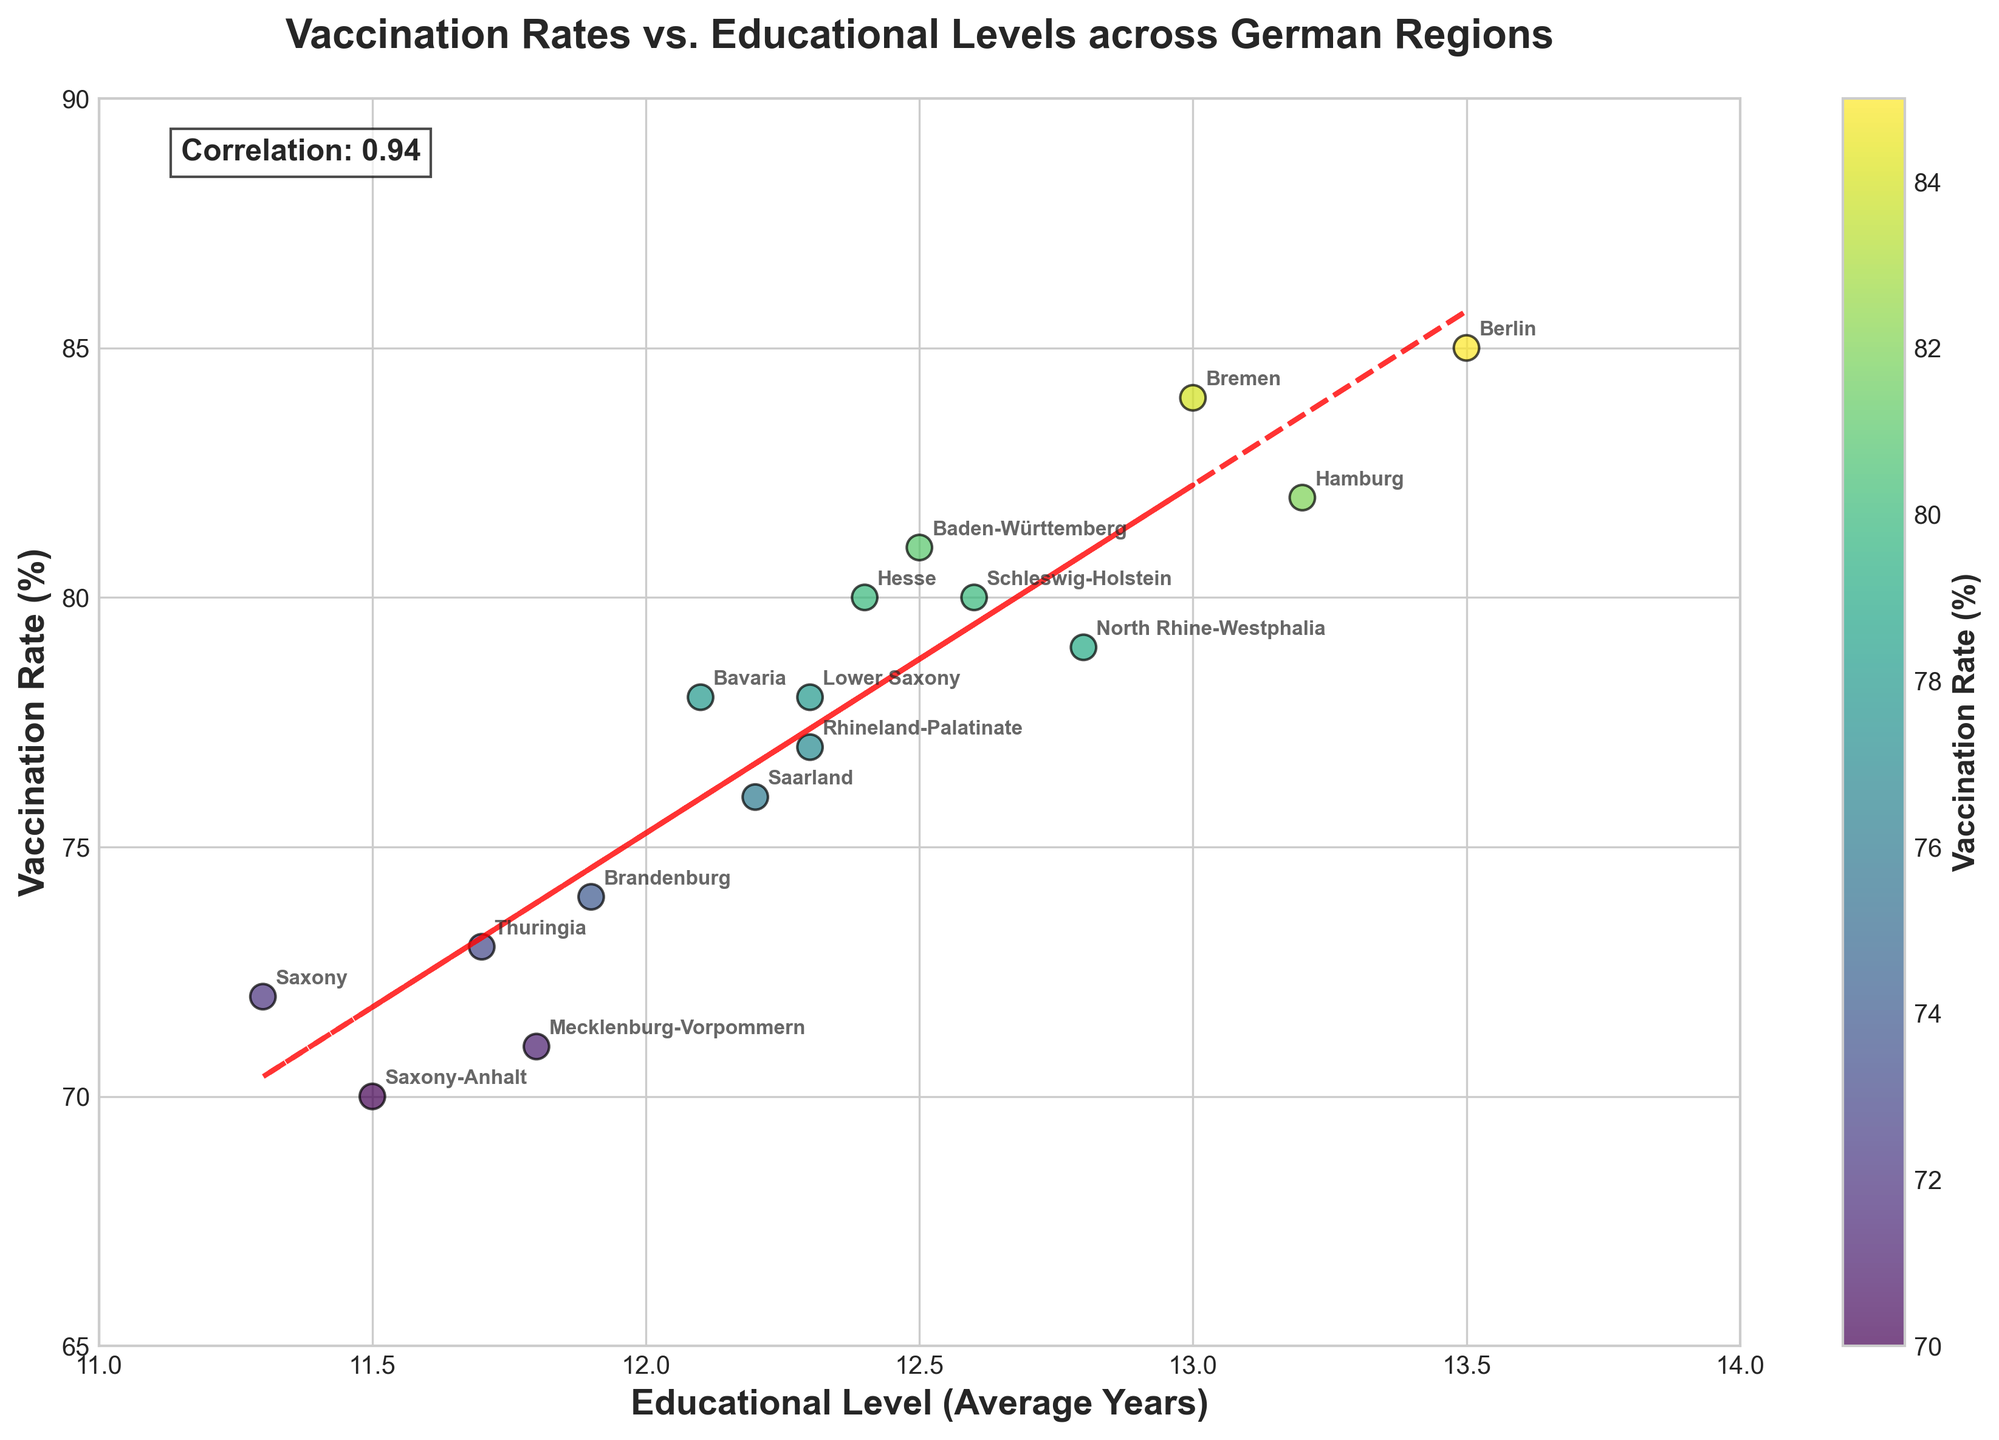What is the title of the figure? The title of the figure is located at the top center. It reads "Vaccination Rates vs. Educational Levels across German Regions." This title directly indicates the relationship being explored in the scatter plot.
Answer: Vaccination Rates vs. Educational Levels across German Regions What are the X-axis and Y-axis labels? The X-axis label is "Educational Level (Average Years)," and the Y-axis label is "Vaccination Rate (%)". These labels provide the variables being plotted on each axis.
Answer: Educational Level (Average Years), Vaccination Rate (%) Which region has the highest vaccination rate? The highest vaccination rate can be identified by looking for the point that is the farthest up along the Y-axis. According to the annotations, Berlin has the highest vaccination rate at 85%.
Answer: Berlin What is the average vaccination rate across all regions? To find the average vaccination rate, sum up all the vaccination rates and then divide by the number of regions. The sum is 78 + 85 + 82 + 72 + 81 + 79 + 80 + 77 + 84 + 76 + 78 + 71 + 70 + 73 + 80 + 74 = 1200. There are 16 regions, so the average is 1200 / 16.
Answer: 75% What is the correlation coefficient between educational level and vaccination rate, and what does it imply? The correlation coefficient is shown as a text box within the plot. It indicates how strongly the two variables are related. The figure shows a correlation coefficient of about 0.81, implying a strong positive relationship between educational level and vaccination rate.
Answer: 0.81 How does the vaccination rate for Bavaria compare to that of Hesse? To compare the vaccination rates, look for the points corresponding to Bavaria and Hesse. Bavaria has a vaccination rate of 78%, while Hesse has a rate of 80%, so Hesse has a slightly higher vaccination rate than Bavaria by 2 percentage points.
Answer: Hesse is higher Which region has the lowest educational level, and what is its vaccination rate? The region with the lowest educational level can be found by identifying the point farthest to the left on the X-axis. Saxony-Anhalt has the lowest educational level at 11.5 years, with a corresponding vaccination rate of 70%.
Answer: Saxony-Anhalt, 70% What trend can be observed from the trend line in the scatter plot? The trend line in the scatter plot shows an upward slope, indicating that as the educational level increases, the vaccination rate also tends to increase. This suggests a positive relationship between the two variables.
Answer: As educational level increases, vaccination rate increases What is the vaccination rate in Schleswig-Holstein, and how does it compare to the overall average? The point for Schleswig-Holstein shows a vaccination rate of 80%. The overall average vaccination rate is 75%. Thus, Schleswig-Holstein's rate is 5 percentage points higher than the average.
Answer: 80%, higher than average 